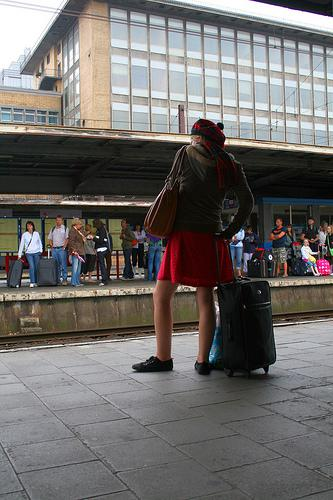Question: who is standing in the foreground?
Choices:
A. A boy.
B. A man.
C. A girl.
D. A woman.
Answer with the letter. Answer: C Question: what is the girl pulling along?
Choices:
A. A dog.
B. Her friend.
C. A parent.
D. A suitcase.
Answer with the letter. Answer: D Question: how many people are in the foreground?
Choices:
A. 0.
B. 5.
C. 3.
D. 1.
Answer with the letter. Answer: D Question: where was this photo taken?
Choices:
A. Airport.
B. Parking lot.
C. A train station.
D. Driveway.
Answer with the letter. Answer: C Question: what are the people waiting for?
Choices:
A. Subway.
B. Airplane.
C. The train.
D. Restaurant table.
Answer with the letter. Answer: C 